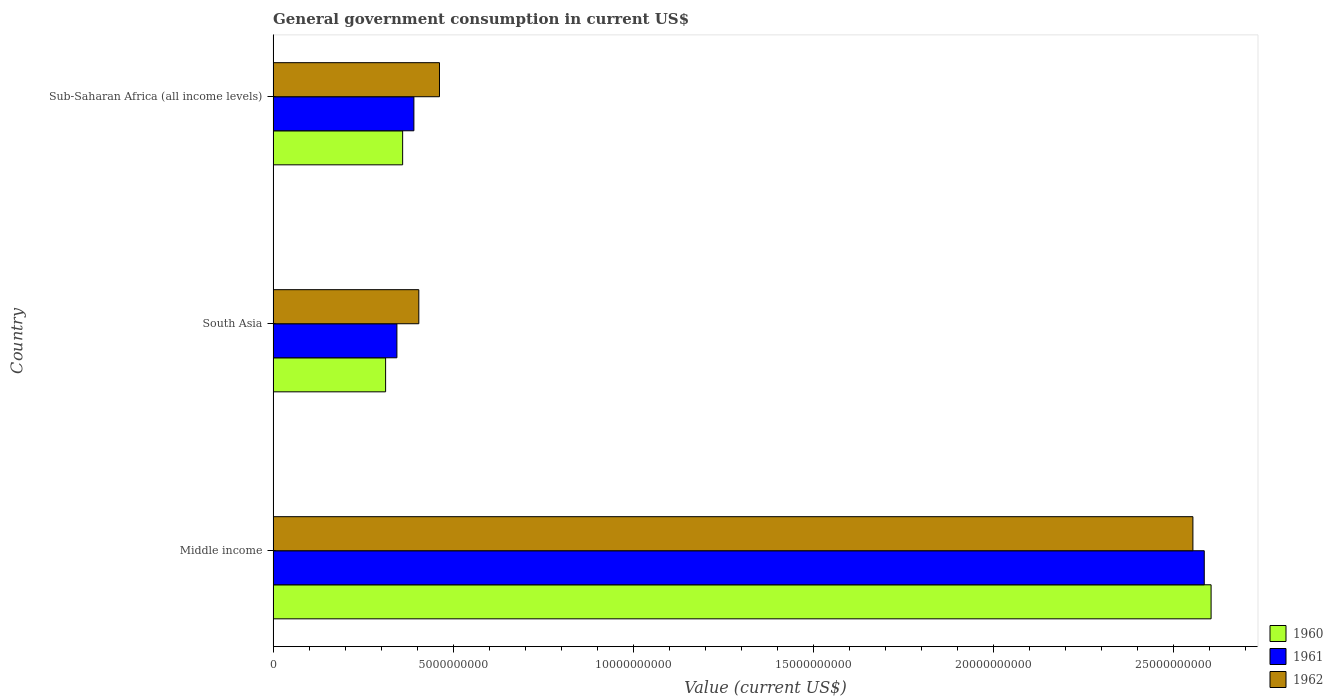How many different coloured bars are there?
Ensure brevity in your answer.  3. How many groups of bars are there?
Ensure brevity in your answer.  3. How many bars are there on the 3rd tick from the top?
Give a very brief answer. 3. How many bars are there on the 1st tick from the bottom?
Provide a short and direct response. 3. What is the label of the 3rd group of bars from the top?
Provide a short and direct response. Middle income. In how many cases, is the number of bars for a given country not equal to the number of legend labels?
Offer a terse response. 0. What is the government conusmption in 1962 in South Asia?
Keep it short and to the point. 4.04e+09. Across all countries, what is the maximum government conusmption in 1961?
Make the answer very short. 2.58e+1. Across all countries, what is the minimum government conusmption in 1960?
Give a very brief answer. 3.12e+09. In which country was the government conusmption in 1961 minimum?
Your response must be concise. South Asia. What is the total government conusmption in 1961 in the graph?
Offer a terse response. 3.32e+1. What is the difference between the government conusmption in 1961 in Middle income and that in South Asia?
Your response must be concise. 2.24e+1. What is the difference between the government conusmption in 1962 in South Asia and the government conusmption in 1961 in Sub-Saharan Africa (all income levels)?
Ensure brevity in your answer.  1.36e+08. What is the average government conusmption in 1961 per country?
Ensure brevity in your answer.  1.11e+1. What is the difference between the government conusmption in 1961 and government conusmption in 1960 in Middle income?
Make the answer very short. -1.90e+08. In how many countries, is the government conusmption in 1961 greater than 7000000000 US$?
Your response must be concise. 1. What is the ratio of the government conusmption in 1960 in Middle income to that in Sub-Saharan Africa (all income levels)?
Your answer should be very brief. 7.24. Is the government conusmption in 1961 in South Asia less than that in Sub-Saharan Africa (all income levels)?
Offer a very short reply. Yes. What is the difference between the highest and the second highest government conusmption in 1960?
Ensure brevity in your answer.  2.24e+1. What is the difference between the highest and the lowest government conusmption in 1962?
Your answer should be compact. 2.15e+1. Is the sum of the government conusmption in 1961 in Middle income and Sub-Saharan Africa (all income levels) greater than the maximum government conusmption in 1962 across all countries?
Provide a short and direct response. Yes. What does the 2nd bar from the top in Sub-Saharan Africa (all income levels) represents?
Provide a short and direct response. 1961. How many bars are there?
Your answer should be very brief. 9. Does the graph contain any zero values?
Your answer should be very brief. No. Does the graph contain grids?
Offer a very short reply. No. What is the title of the graph?
Make the answer very short. General government consumption in current US$. What is the label or title of the X-axis?
Make the answer very short. Value (current US$). What is the Value (current US$) in 1960 in Middle income?
Your response must be concise. 2.60e+1. What is the Value (current US$) of 1961 in Middle income?
Offer a very short reply. 2.58e+1. What is the Value (current US$) in 1962 in Middle income?
Ensure brevity in your answer.  2.55e+1. What is the Value (current US$) in 1960 in South Asia?
Provide a short and direct response. 3.12e+09. What is the Value (current US$) of 1961 in South Asia?
Your answer should be compact. 3.44e+09. What is the Value (current US$) in 1962 in South Asia?
Ensure brevity in your answer.  4.04e+09. What is the Value (current US$) in 1960 in Sub-Saharan Africa (all income levels)?
Give a very brief answer. 3.60e+09. What is the Value (current US$) of 1961 in Sub-Saharan Africa (all income levels)?
Provide a short and direct response. 3.91e+09. What is the Value (current US$) of 1962 in Sub-Saharan Africa (all income levels)?
Offer a very short reply. 4.62e+09. Across all countries, what is the maximum Value (current US$) in 1960?
Provide a succinct answer. 2.60e+1. Across all countries, what is the maximum Value (current US$) of 1961?
Keep it short and to the point. 2.58e+1. Across all countries, what is the maximum Value (current US$) of 1962?
Make the answer very short. 2.55e+1. Across all countries, what is the minimum Value (current US$) of 1960?
Make the answer very short. 3.12e+09. Across all countries, what is the minimum Value (current US$) of 1961?
Provide a succinct answer. 3.44e+09. Across all countries, what is the minimum Value (current US$) of 1962?
Your answer should be very brief. 4.04e+09. What is the total Value (current US$) of 1960 in the graph?
Offer a terse response. 3.28e+1. What is the total Value (current US$) of 1961 in the graph?
Your answer should be very brief. 3.32e+1. What is the total Value (current US$) in 1962 in the graph?
Ensure brevity in your answer.  3.42e+1. What is the difference between the Value (current US$) in 1960 in Middle income and that in South Asia?
Your response must be concise. 2.29e+1. What is the difference between the Value (current US$) in 1961 in Middle income and that in South Asia?
Make the answer very short. 2.24e+1. What is the difference between the Value (current US$) in 1962 in Middle income and that in South Asia?
Your response must be concise. 2.15e+1. What is the difference between the Value (current US$) in 1960 in Middle income and that in Sub-Saharan Africa (all income levels)?
Keep it short and to the point. 2.24e+1. What is the difference between the Value (current US$) in 1961 in Middle income and that in Sub-Saharan Africa (all income levels)?
Give a very brief answer. 2.19e+1. What is the difference between the Value (current US$) of 1962 in Middle income and that in Sub-Saharan Africa (all income levels)?
Your response must be concise. 2.09e+1. What is the difference between the Value (current US$) of 1960 in South Asia and that in Sub-Saharan Africa (all income levels)?
Keep it short and to the point. -4.73e+08. What is the difference between the Value (current US$) in 1961 in South Asia and that in Sub-Saharan Africa (all income levels)?
Your response must be concise. -4.72e+08. What is the difference between the Value (current US$) in 1962 in South Asia and that in Sub-Saharan Africa (all income levels)?
Provide a succinct answer. -5.74e+08. What is the difference between the Value (current US$) in 1960 in Middle income and the Value (current US$) in 1961 in South Asia?
Make the answer very short. 2.26e+1. What is the difference between the Value (current US$) in 1960 in Middle income and the Value (current US$) in 1962 in South Asia?
Your response must be concise. 2.20e+1. What is the difference between the Value (current US$) in 1961 in Middle income and the Value (current US$) in 1962 in South Asia?
Give a very brief answer. 2.18e+1. What is the difference between the Value (current US$) of 1960 in Middle income and the Value (current US$) of 1961 in Sub-Saharan Africa (all income levels)?
Make the answer very short. 2.21e+1. What is the difference between the Value (current US$) in 1960 in Middle income and the Value (current US$) in 1962 in Sub-Saharan Africa (all income levels)?
Offer a terse response. 2.14e+1. What is the difference between the Value (current US$) of 1961 in Middle income and the Value (current US$) of 1962 in Sub-Saharan Africa (all income levels)?
Your response must be concise. 2.12e+1. What is the difference between the Value (current US$) in 1960 in South Asia and the Value (current US$) in 1961 in Sub-Saharan Africa (all income levels)?
Provide a short and direct response. -7.85e+08. What is the difference between the Value (current US$) in 1960 in South Asia and the Value (current US$) in 1962 in Sub-Saharan Africa (all income levels)?
Offer a terse response. -1.50e+09. What is the difference between the Value (current US$) in 1961 in South Asia and the Value (current US$) in 1962 in Sub-Saharan Africa (all income levels)?
Provide a short and direct response. -1.18e+09. What is the average Value (current US$) in 1960 per country?
Provide a short and direct response. 1.09e+1. What is the average Value (current US$) in 1961 per country?
Provide a succinct answer. 1.11e+1. What is the average Value (current US$) of 1962 per country?
Your answer should be very brief. 1.14e+1. What is the difference between the Value (current US$) of 1960 and Value (current US$) of 1961 in Middle income?
Your answer should be compact. 1.90e+08. What is the difference between the Value (current US$) of 1960 and Value (current US$) of 1962 in Middle income?
Give a very brief answer. 5.05e+08. What is the difference between the Value (current US$) of 1961 and Value (current US$) of 1962 in Middle income?
Offer a very short reply. 3.15e+08. What is the difference between the Value (current US$) of 1960 and Value (current US$) of 1961 in South Asia?
Provide a short and direct response. -3.13e+08. What is the difference between the Value (current US$) in 1960 and Value (current US$) in 1962 in South Asia?
Your response must be concise. -9.22e+08. What is the difference between the Value (current US$) of 1961 and Value (current US$) of 1962 in South Asia?
Offer a very short reply. -6.08e+08. What is the difference between the Value (current US$) of 1960 and Value (current US$) of 1961 in Sub-Saharan Africa (all income levels)?
Ensure brevity in your answer.  -3.13e+08. What is the difference between the Value (current US$) of 1960 and Value (current US$) of 1962 in Sub-Saharan Africa (all income levels)?
Ensure brevity in your answer.  -1.02e+09. What is the difference between the Value (current US$) of 1961 and Value (current US$) of 1962 in Sub-Saharan Africa (all income levels)?
Provide a short and direct response. -7.10e+08. What is the ratio of the Value (current US$) in 1960 in Middle income to that in South Asia?
Provide a succinct answer. 8.34. What is the ratio of the Value (current US$) of 1961 in Middle income to that in South Asia?
Keep it short and to the point. 7.52. What is the ratio of the Value (current US$) of 1962 in Middle income to that in South Asia?
Provide a short and direct response. 6.31. What is the ratio of the Value (current US$) of 1960 in Middle income to that in Sub-Saharan Africa (all income levels)?
Your answer should be very brief. 7.24. What is the ratio of the Value (current US$) of 1961 in Middle income to that in Sub-Saharan Africa (all income levels)?
Make the answer very short. 6.61. What is the ratio of the Value (current US$) of 1962 in Middle income to that in Sub-Saharan Africa (all income levels)?
Offer a terse response. 5.53. What is the ratio of the Value (current US$) of 1960 in South Asia to that in Sub-Saharan Africa (all income levels)?
Provide a short and direct response. 0.87. What is the ratio of the Value (current US$) of 1961 in South Asia to that in Sub-Saharan Africa (all income levels)?
Offer a very short reply. 0.88. What is the ratio of the Value (current US$) of 1962 in South Asia to that in Sub-Saharan Africa (all income levels)?
Your answer should be very brief. 0.88. What is the difference between the highest and the second highest Value (current US$) in 1960?
Ensure brevity in your answer.  2.24e+1. What is the difference between the highest and the second highest Value (current US$) in 1961?
Give a very brief answer. 2.19e+1. What is the difference between the highest and the second highest Value (current US$) in 1962?
Ensure brevity in your answer.  2.09e+1. What is the difference between the highest and the lowest Value (current US$) of 1960?
Keep it short and to the point. 2.29e+1. What is the difference between the highest and the lowest Value (current US$) of 1961?
Your answer should be very brief. 2.24e+1. What is the difference between the highest and the lowest Value (current US$) of 1962?
Provide a succinct answer. 2.15e+1. 